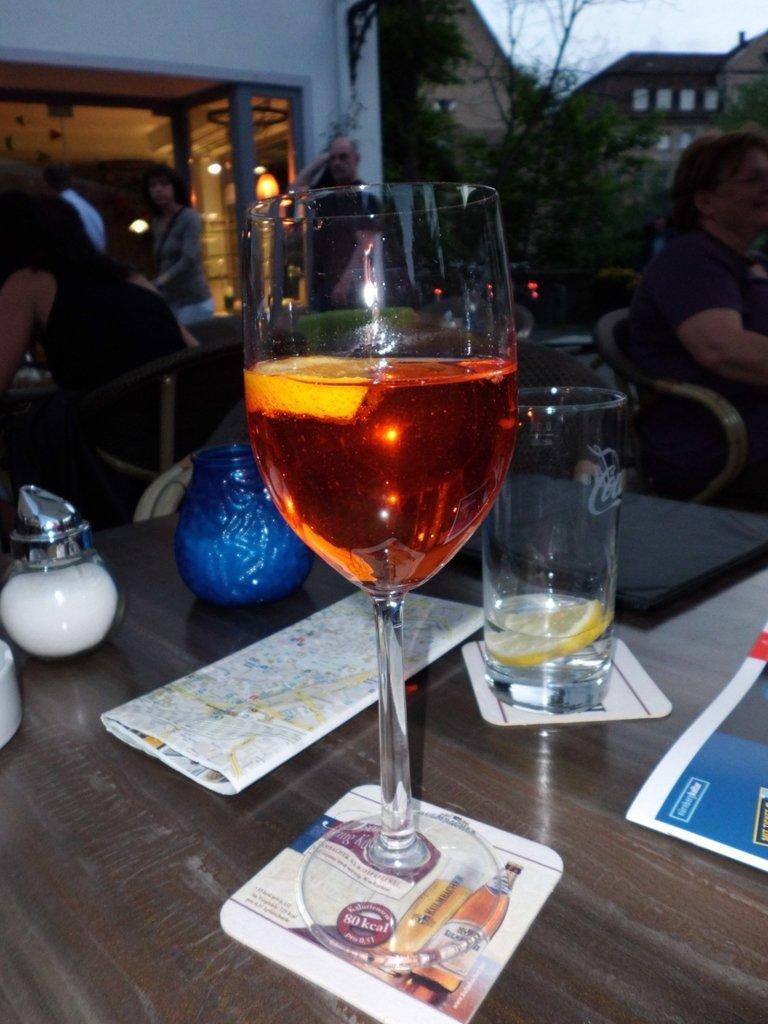In one or two sentences, can you explain what this image depicts? In this picture there is a wine glass with a red liquid in it and on the table there are multiple objects like glass ,notebook, glass container. In the background we observe many people sitting on the tables , plants , a glass door and two houses. 